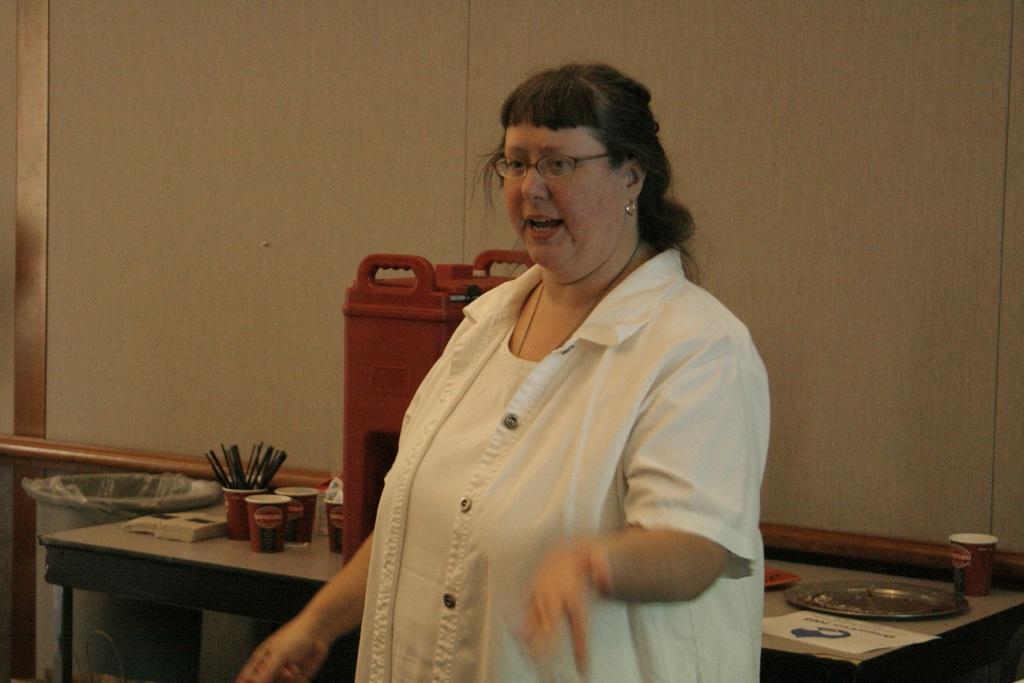How would you summarize this image in a sentence or two? Here in this picture we can see a lady with white shirt. She is standing. She is talking. She is wearing a spectacles. Behind her there is a table. On that table there are some glasses. In that there some things, black color things. Beside that table there is dustbin with plastic cover. On that table we can see a red can. On the table right corner we can see a white paper, a plate. Behind that there is a wall. 